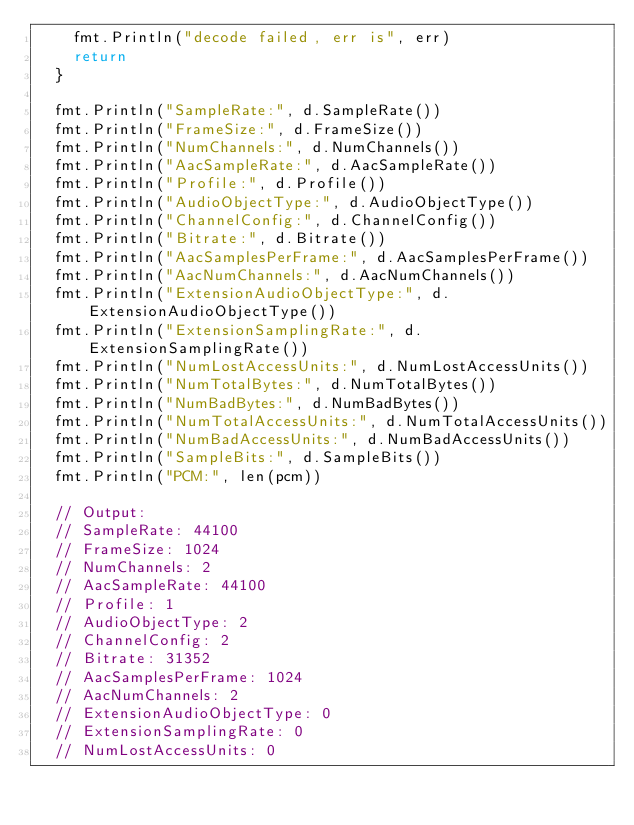Convert code to text. <code><loc_0><loc_0><loc_500><loc_500><_Go_>		fmt.Println("decode failed, err is", err)
		return
	}

	fmt.Println("SampleRate:", d.SampleRate())
	fmt.Println("FrameSize:", d.FrameSize())
	fmt.Println("NumChannels:", d.NumChannels())
	fmt.Println("AacSampleRate:", d.AacSampleRate())
	fmt.Println("Profile:", d.Profile())
	fmt.Println("AudioObjectType:", d.AudioObjectType())
	fmt.Println("ChannelConfig:", d.ChannelConfig())
	fmt.Println("Bitrate:", d.Bitrate())
	fmt.Println("AacSamplesPerFrame:", d.AacSamplesPerFrame())
	fmt.Println("AacNumChannels:", d.AacNumChannels())
	fmt.Println("ExtensionAudioObjectType:", d.ExtensionAudioObjectType())
	fmt.Println("ExtensionSamplingRate:", d.ExtensionSamplingRate())
	fmt.Println("NumLostAccessUnits:", d.NumLostAccessUnits())
	fmt.Println("NumTotalBytes:", d.NumTotalBytes())
	fmt.Println("NumBadBytes:", d.NumBadBytes())
	fmt.Println("NumTotalAccessUnits:", d.NumTotalAccessUnits())
	fmt.Println("NumBadAccessUnits:", d.NumBadAccessUnits())
	fmt.Println("SampleBits:", d.SampleBits())
	fmt.Println("PCM:", len(pcm))

	// Output:
	// SampleRate: 44100
	// FrameSize: 1024
	// NumChannels: 2
	// AacSampleRate: 44100
	// Profile: 1
	// AudioObjectType: 2
	// ChannelConfig: 2
	// Bitrate: 31352
	// AacSamplesPerFrame: 1024
	// AacNumChannels: 2
	// ExtensionAudioObjectType: 0
	// ExtensionSamplingRate: 0
	// NumLostAccessUnits: 0</code> 